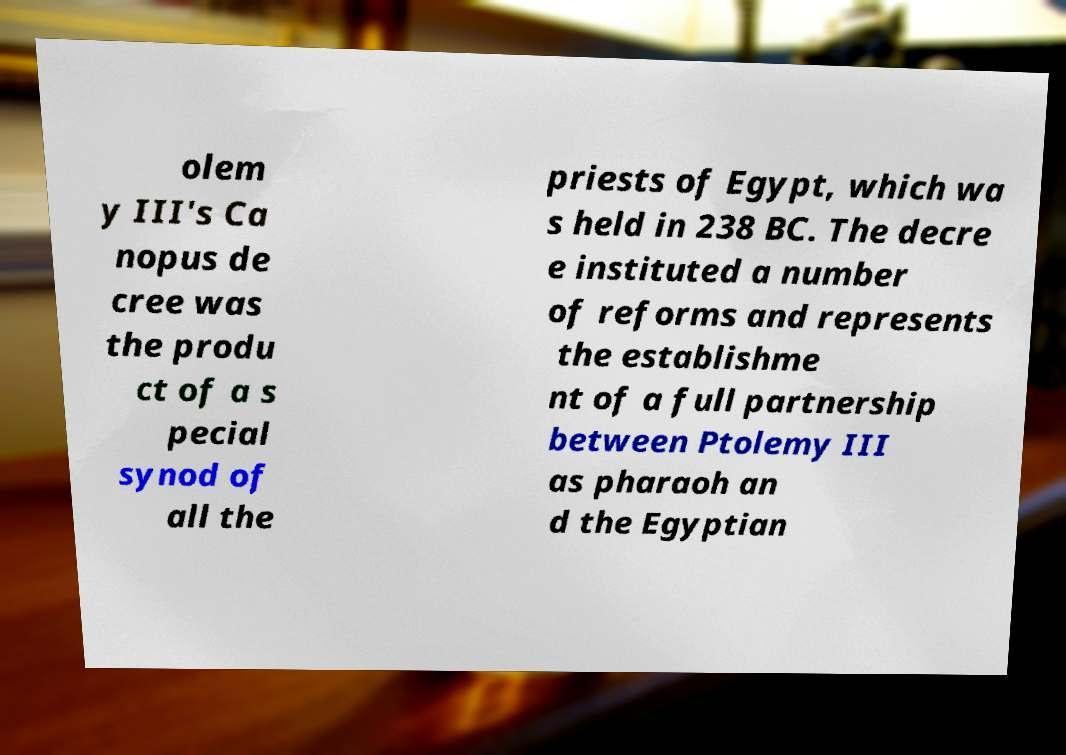Could you assist in decoding the text presented in this image and type it out clearly? olem y III's Ca nopus de cree was the produ ct of a s pecial synod of all the priests of Egypt, which wa s held in 238 BC. The decre e instituted a number of reforms and represents the establishme nt of a full partnership between Ptolemy III as pharaoh an d the Egyptian 